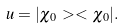<formula> <loc_0><loc_0><loc_500><loc_500>u = | \chi _ { 0 } \, > < \, \chi _ { 0 } | .</formula> 